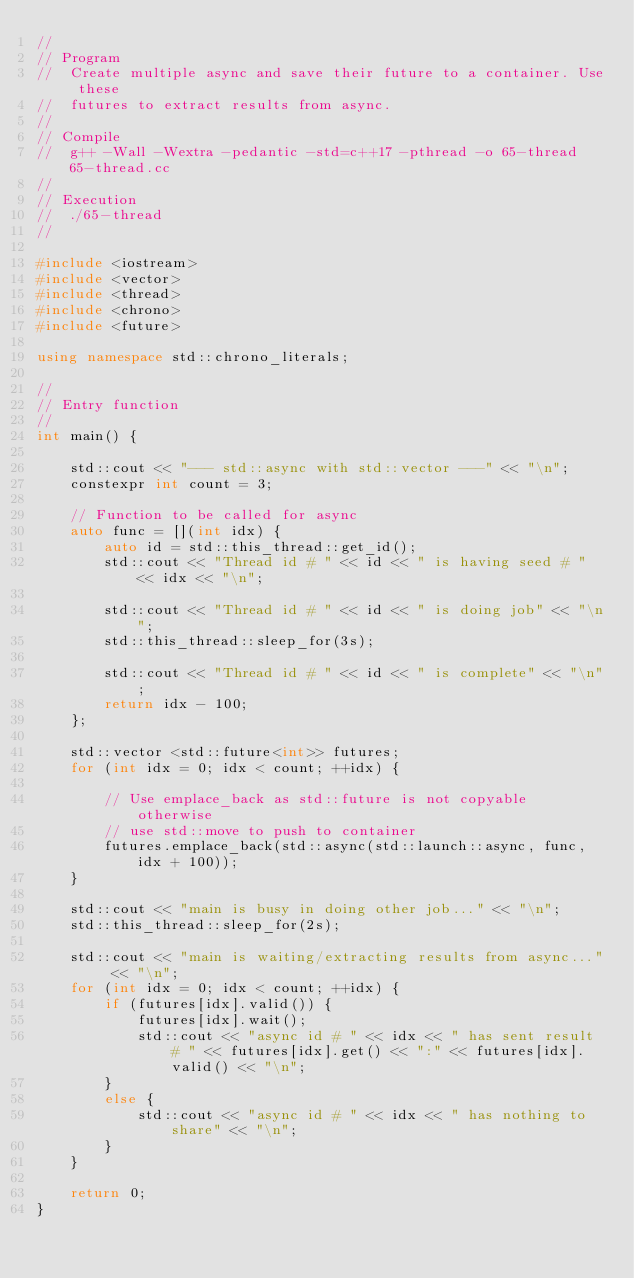Convert code to text. <code><loc_0><loc_0><loc_500><loc_500><_C++_>//
// Program
//  Create multiple async and save their future to a container. Use these 
//  futures to extract results from async.
//
// Compile
//  g++ -Wall -Wextra -pedantic -std=c++17 -pthread -o 65-thread 65-thread.cc
//
// Execution
//  ./65-thread
//

#include <iostream>
#include <vector>
#include <thread>
#include <chrono>
#include <future>

using namespace std::chrono_literals;

//
// Entry function
//
int main() {

    std::cout << "--- std::async with std::vector ---" << "\n";
    constexpr int count = 3;

    // Function to be called for async
    auto func = [](int idx) {
        auto id = std::this_thread::get_id();
        std::cout << "Thread id # " << id << " is having seed # " << idx << "\n";

        std::cout << "Thread id # " << id << " is doing job" << "\n";
        std::this_thread::sleep_for(3s);

        std::cout << "Thread id # " << id << " is complete" << "\n";
        return idx - 100;
    };

    std::vector <std::future<int>> futures;
    for (int idx = 0; idx < count; ++idx) {

        // Use emplace_back as std::future is not copyable otherwise 
        // use std::move to push to container
        futures.emplace_back(std::async(std::launch::async, func, idx + 100));
    }

    std::cout << "main is busy in doing other job..." << "\n";
    std::this_thread::sleep_for(2s);

    std::cout << "main is waiting/extracting results from async..." << "\n";
    for (int idx = 0; idx < count; ++idx) {
        if (futures[idx].valid()) {
            futures[idx].wait();
            std::cout << "async id # " << idx << " has sent result # " << futures[idx].get() << ":" << futures[idx].valid() << "\n";
        }
        else {
            std::cout << "async id # " << idx << " has nothing to share" << "\n";
        }
    }

    return 0;
}
</code> 